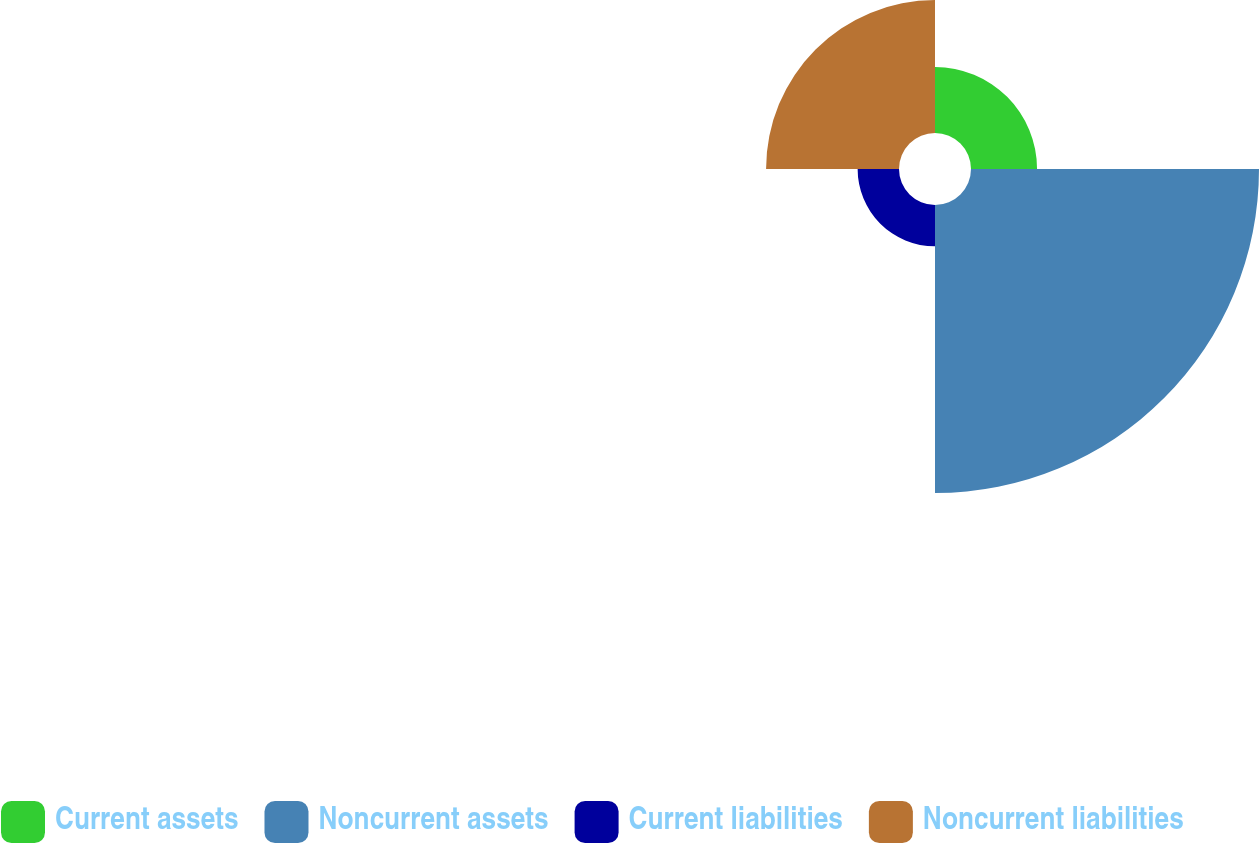Convert chart to OTSL. <chart><loc_0><loc_0><loc_500><loc_500><pie_chart><fcel>Current assets<fcel>Noncurrent assets<fcel>Current liabilities<fcel>Noncurrent liabilities<nl><fcel>12.5%<fcel>54.51%<fcel>7.83%<fcel>25.16%<nl></chart> 